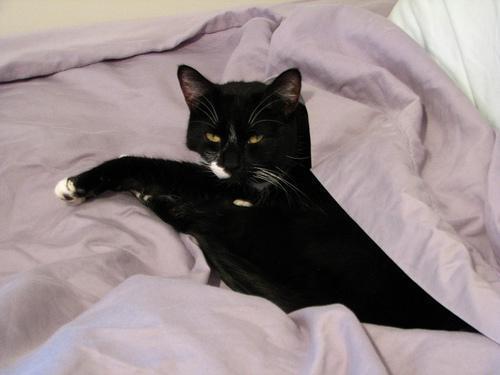How many animals are there?
Give a very brief answer. 1. How many white spots does the cat have?
Give a very brief answer. 3. 